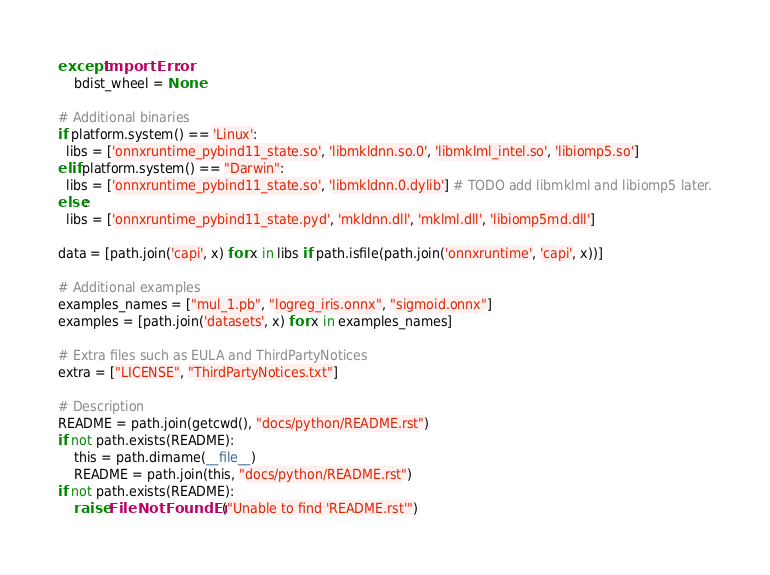Convert code to text. <code><loc_0><loc_0><loc_500><loc_500><_Python_>except ImportError:
    bdist_wheel = None

# Additional binaries
if platform.system() == 'Linux':
  libs = ['onnxruntime_pybind11_state.so', 'libmkldnn.so.0', 'libmklml_intel.so', 'libiomp5.so']
elif platform.system() == "Darwin":
  libs = ['onnxruntime_pybind11_state.so', 'libmkldnn.0.dylib'] # TODO add libmklml and libiomp5 later.
else:
  libs = ['onnxruntime_pybind11_state.pyd', 'mkldnn.dll', 'mklml.dll', 'libiomp5md.dll']

data = [path.join('capi', x) for x in libs if path.isfile(path.join('onnxruntime', 'capi', x))]

# Additional examples
examples_names = ["mul_1.pb", "logreg_iris.onnx", "sigmoid.onnx"]
examples = [path.join('datasets', x) for x in examples_names]

# Extra files such as EULA and ThirdPartyNotices
extra = ["LICENSE", "ThirdPartyNotices.txt"]

# Description
README = path.join(getcwd(), "docs/python/README.rst")
if not path.exists(README):
    this = path.dirname(__file__)
    README = path.join(this, "docs/python/README.rst")
if not path.exists(README):
    raise FileNotFoundError("Unable to find 'README.rst'")</code> 